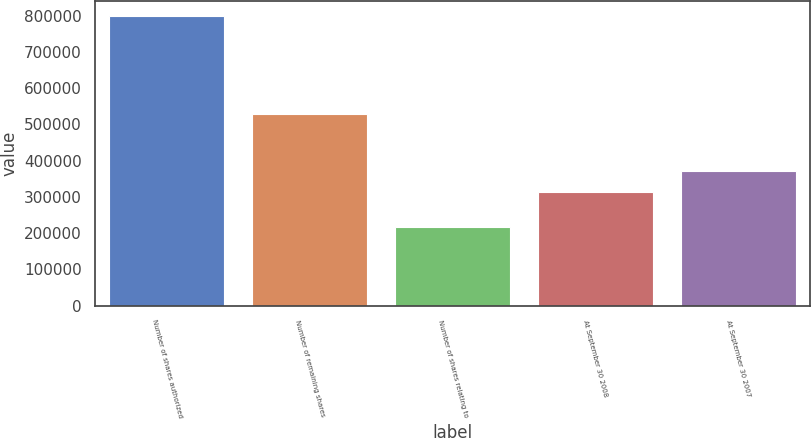<chart> <loc_0><loc_0><loc_500><loc_500><bar_chart><fcel>Number of shares authorized<fcel>Number of remaining shares<fcel>Number of shares relating to<fcel>At September 30 2008<fcel>At September 30 2007<nl><fcel>800000<fcel>530000<fcel>216500<fcel>313500<fcel>371850<nl></chart> 